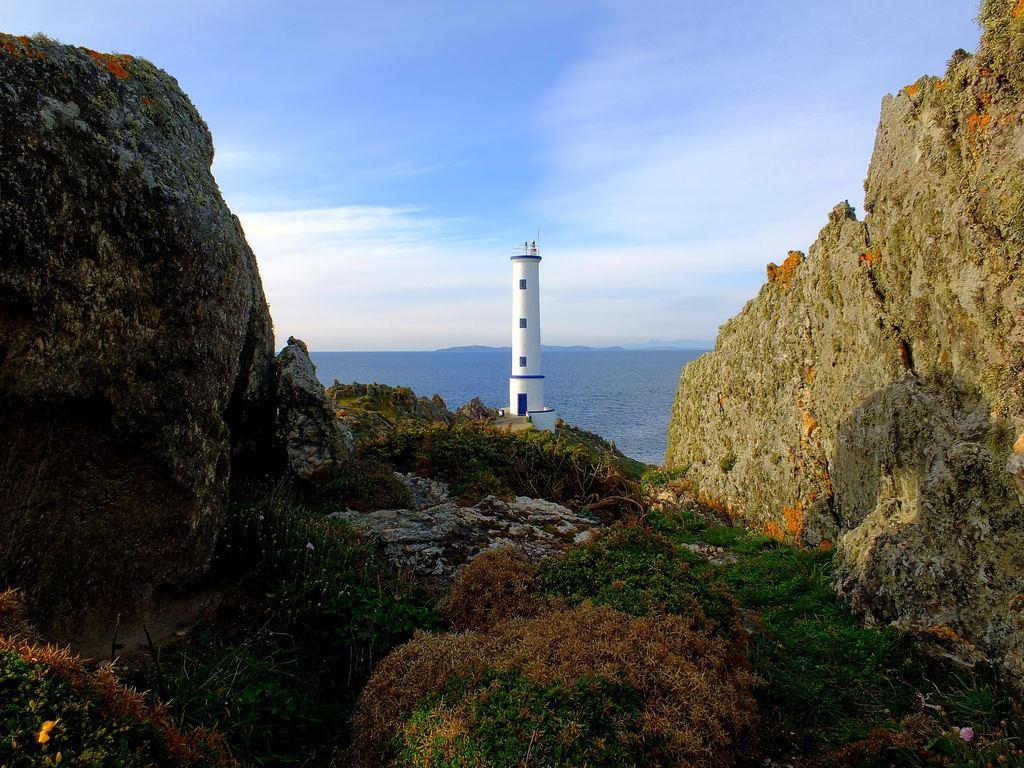What type of vegetation is present in the image? There is grass in the image. What structure can be seen in the image? There is a lighthouse in the image. What can be seen in the distance in the image? There is water visible in the background of the image. What is visible in the sky in the background of the image? There are clouds in the sky in the background of the image. What type of fiction is being read by the flock of birds in the image? There are no birds or fiction present in the image; it features grass, a lighthouse, water, and clouds. Which direction is the lighthouse pointing towards in the image? The facts provided do not specify the direction the lighthouse is pointing towards. 